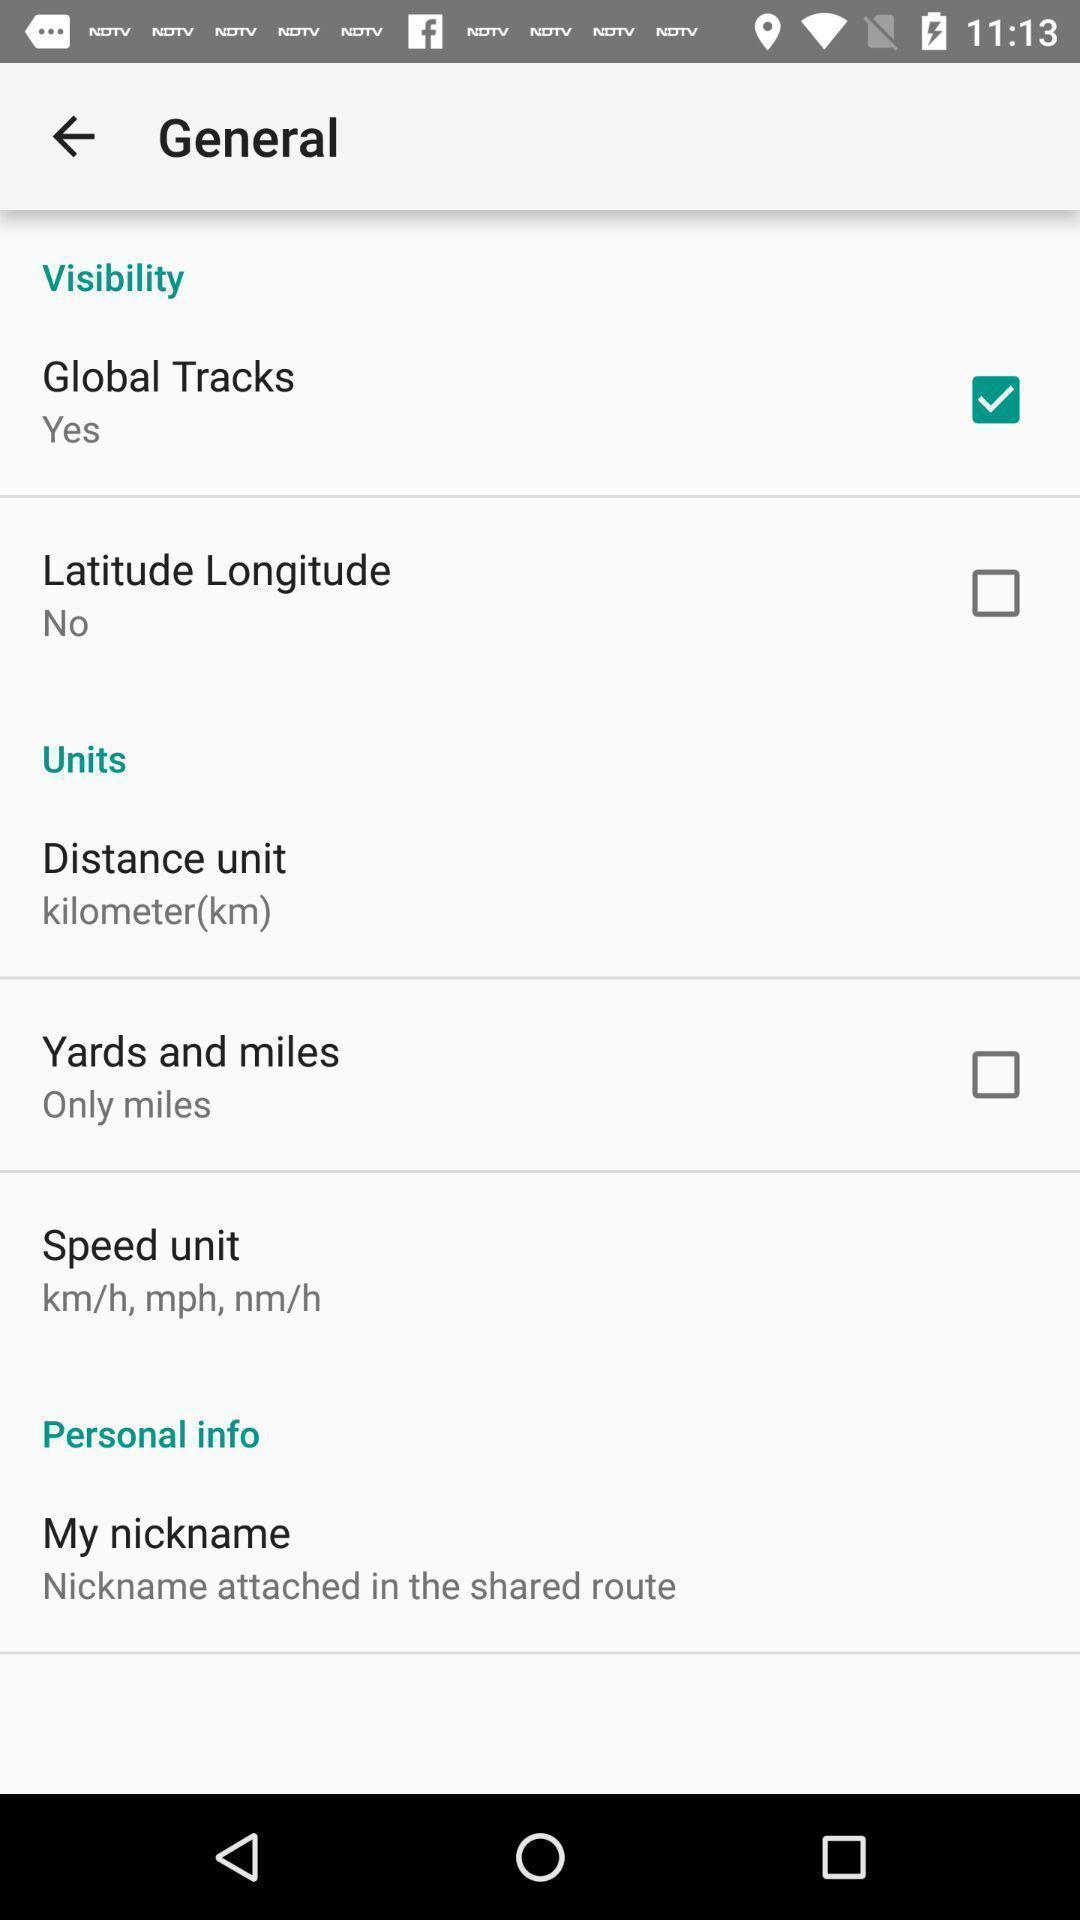Summarize the information in this screenshot. Tracking of outdoor activities with options. 